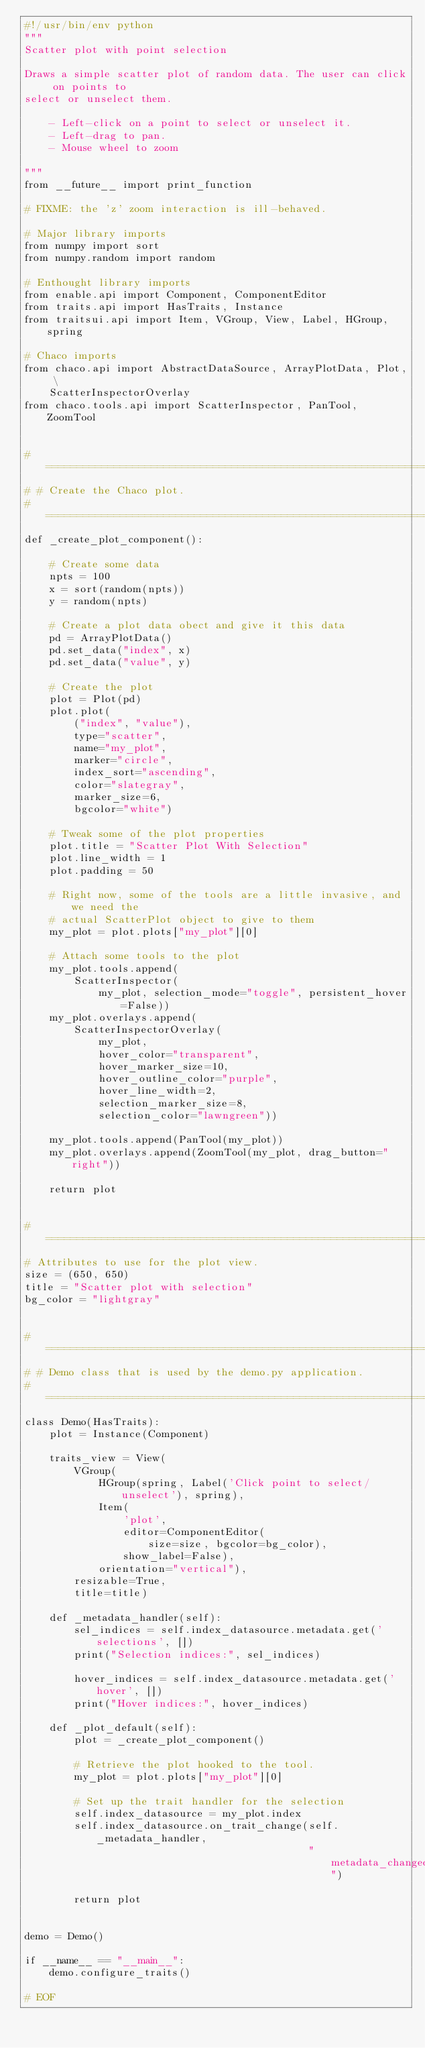<code> <loc_0><loc_0><loc_500><loc_500><_Python_>#!/usr/bin/env python
"""
Scatter plot with point selection

Draws a simple scatter plot of random data. The user can click on points to
select or unselect them.

    - Left-click on a point to select or unselect it.
    - Left-drag to pan.
    - Mouse wheel to zoom

"""
from __future__ import print_function

# FIXME: the 'z' zoom interaction is ill-behaved.

# Major library imports
from numpy import sort
from numpy.random import random

# Enthought library imports
from enable.api import Component, ComponentEditor
from traits.api import HasTraits, Instance
from traitsui.api import Item, VGroup, View, Label, HGroup, spring

# Chaco imports
from chaco.api import AbstractDataSource, ArrayPlotData, Plot, \
    ScatterInspectorOverlay
from chaco.tools.api import ScatterInspector, PanTool, ZoomTool


#===============================================================================
# # Create the Chaco plot.
#===============================================================================
def _create_plot_component():

    # Create some data
    npts = 100
    x = sort(random(npts))
    y = random(npts)

    # Create a plot data obect and give it this data
    pd = ArrayPlotData()
    pd.set_data("index", x)
    pd.set_data("value", y)

    # Create the plot
    plot = Plot(pd)
    plot.plot(
        ("index", "value"),
        type="scatter",
        name="my_plot",
        marker="circle",
        index_sort="ascending",
        color="slategray",
        marker_size=6,
        bgcolor="white")

    # Tweak some of the plot properties
    plot.title = "Scatter Plot With Selection"
    plot.line_width = 1
    plot.padding = 50

    # Right now, some of the tools are a little invasive, and we need the
    # actual ScatterPlot object to give to them
    my_plot = plot.plots["my_plot"][0]

    # Attach some tools to the plot
    my_plot.tools.append(
        ScatterInspector(
            my_plot, selection_mode="toggle", persistent_hover=False))
    my_plot.overlays.append(
        ScatterInspectorOverlay(
            my_plot,
            hover_color="transparent",
            hover_marker_size=10,
            hover_outline_color="purple",
            hover_line_width=2,
            selection_marker_size=8,
            selection_color="lawngreen"))

    my_plot.tools.append(PanTool(my_plot))
    my_plot.overlays.append(ZoomTool(my_plot, drag_button="right"))

    return plot


#===============================================================================
# Attributes to use for the plot view.
size = (650, 650)
title = "Scatter plot with selection"
bg_color = "lightgray"


#===============================================================================
# # Demo class that is used by the demo.py application.
#===============================================================================
class Demo(HasTraits):
    plot = Instance(Component)

    traits_view = View(
        VGroup(
            HGroup(spring, Label('Click point to select/unselect'), spring),
            Item(
                'plot',
                editor=ComponentEditor(
                    size=size, bgcolor=bg_color),
                show_label=False),
            orientation="vertical"),
        resizable=True,
        title=title)

    def _metadata_handler(self):
        sel_indices = self.index_datasource.metadata.get('selections', [])
        print("Selection indices:", sel_indices)

        hover_indices = self.index_datasource.metadata.get('hover', [])
        print("Hover indices:", hover_indices)

    def _plot_default(self):
        plot = _create_plot_component()

        # Retrieve the plot hooked to the tool.
        my_plot = plot.plots["my_plot"][0]

        # Set up the trait handler for the selection
        self.index_datasource = my_plot.index
        self.index_datasource.on_trait_change(self._metadata_handler,
                                              "metadata_changed")

        return plot


demo = Demo()

if __name__ == "__main__":
    demo.configure_traits()

# EOF
</code> 